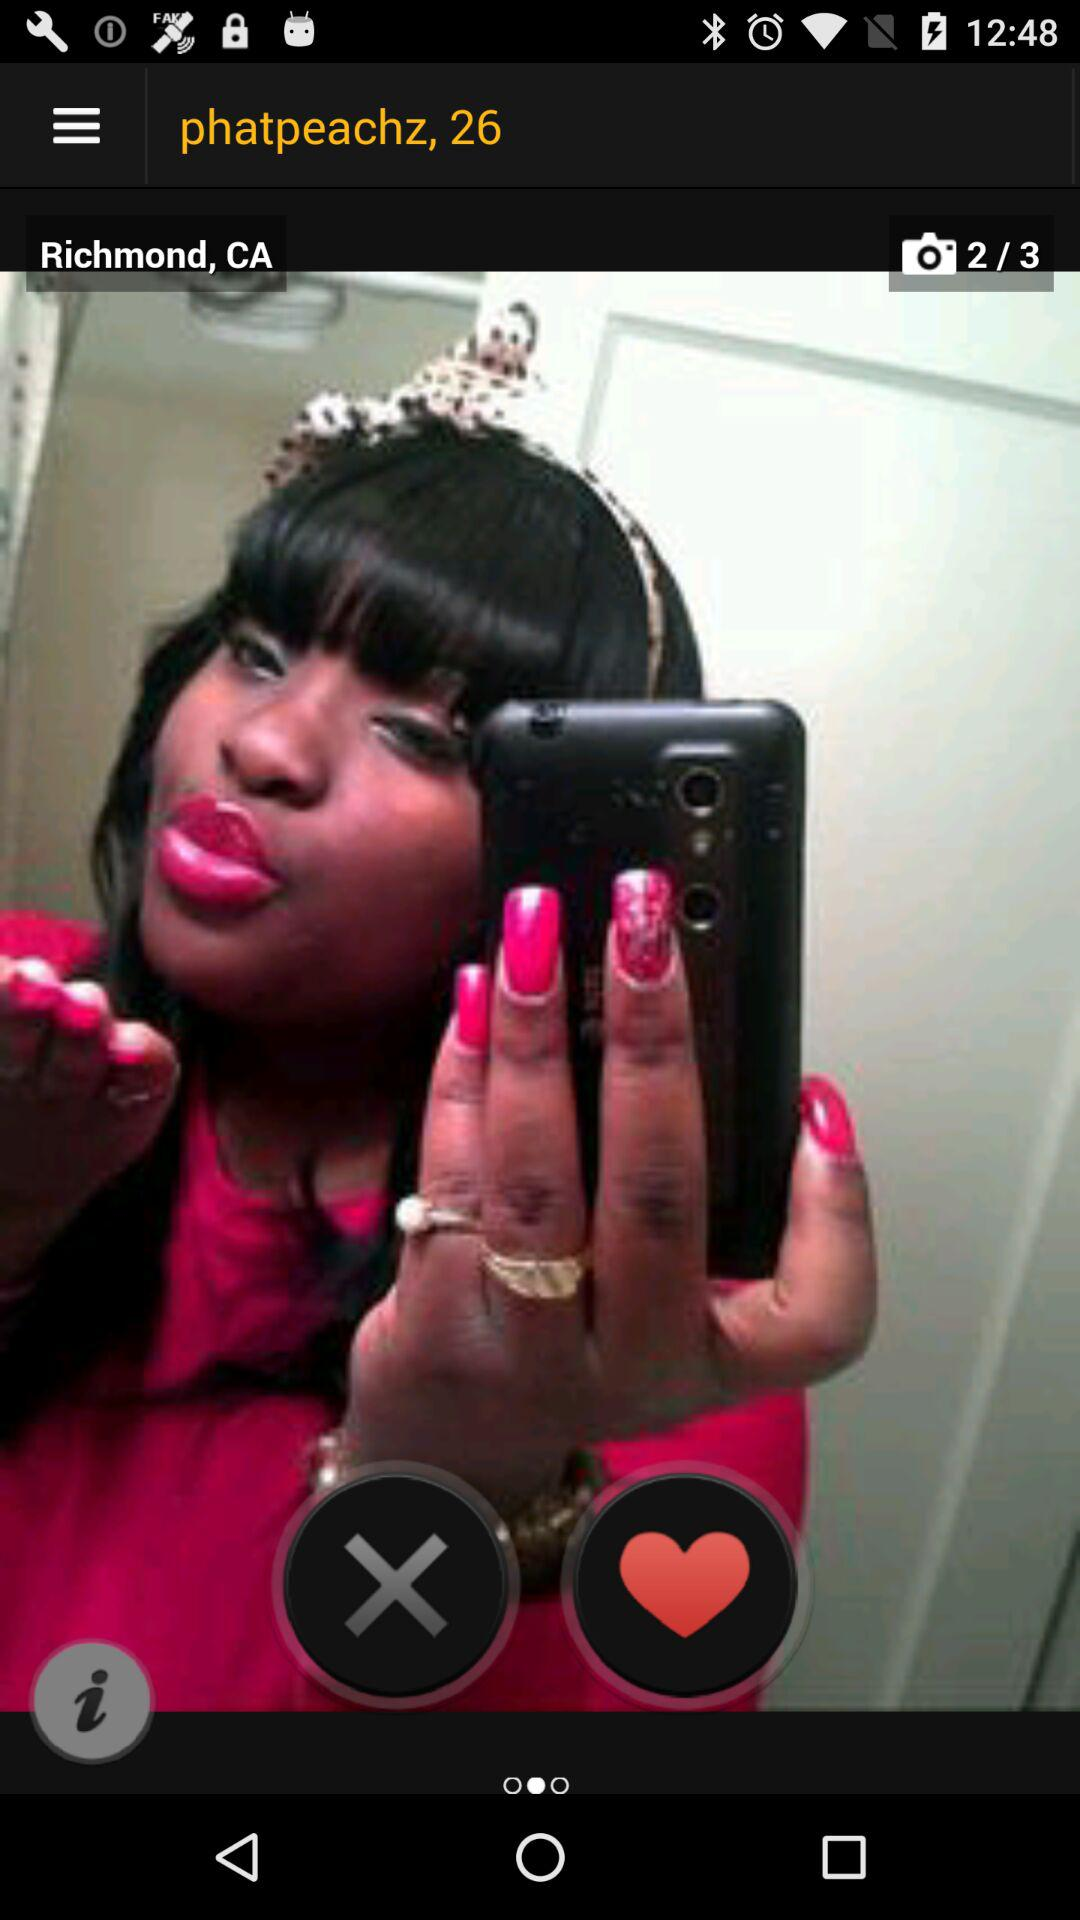Which photo is the person currently on? The person is currently on the second photo. 